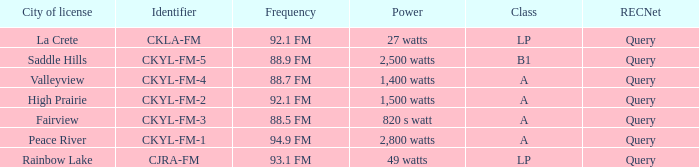What is the city of license that has a 1,400 watts power Valleyview. 